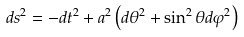Convert formula to latex. <formula><loc_0><loc_0><loc_500><loc_500>d s ^ { 2 } = - d t ^ { 2 } + a ^ { 2 } \left ( d \theta ^ { 2 } + \sin ^ { 2 } \theta d \varphi ^ { 2 } \right )</formula> 